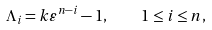<formula> <loc_0><loc_0><loc_500><loc_500>\Lambda _ { i } = k \varepsilon ^ { n - i } - 1 , \quad 1 \leq i \leq n ,</formula> 